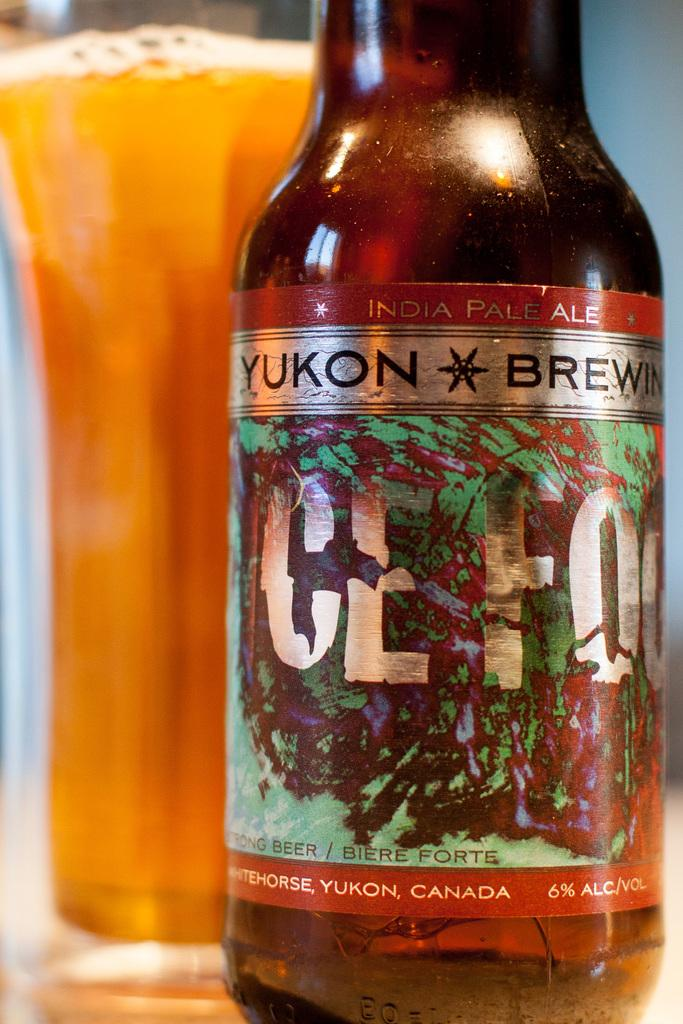What is inside the bottle in the image? There is a drink inside the bottle in the image. What can be seen on the bottle's surface? The bottle has a sticker with text on it. What other container with a drink is present in the image? There is a glass with a drink next to the bottle. What type of pencil is being used to draw on the roof in the image? There is no pencil or roof present in the image; it only features a bottle and a glass with drinks. 